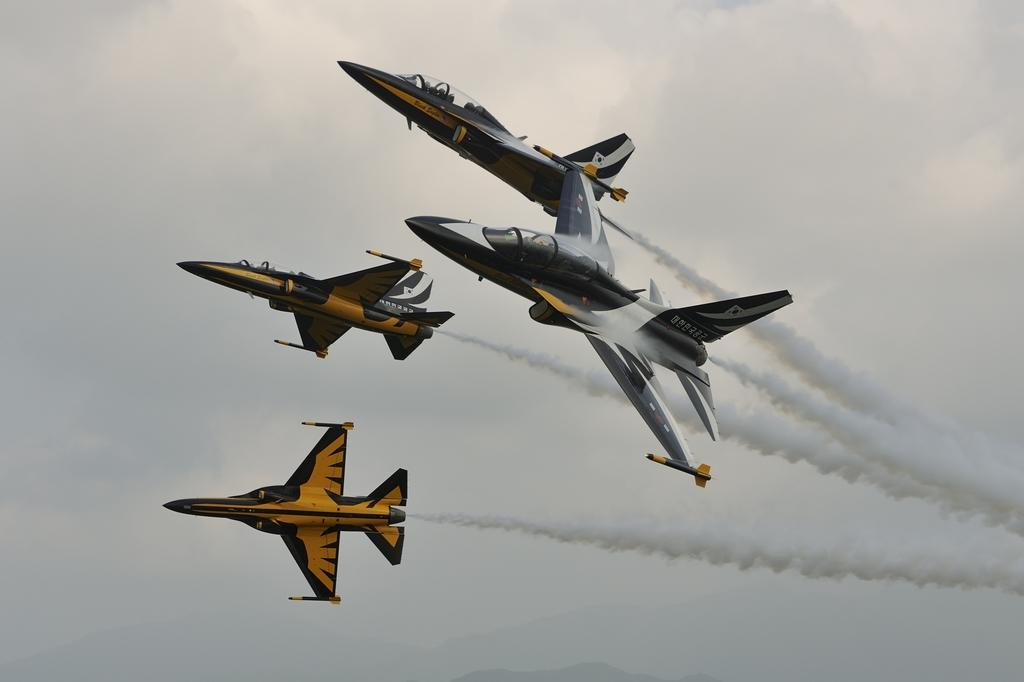What is the main subject of the image? The main subject of the image is aircrafts. Where are the aircrafts located in the image? The aircrafts are in the sky. What type of net can be seen supporting the aircrafts in the image? There is no net present in the image; the aircrafts are in the sky without any visible support. 